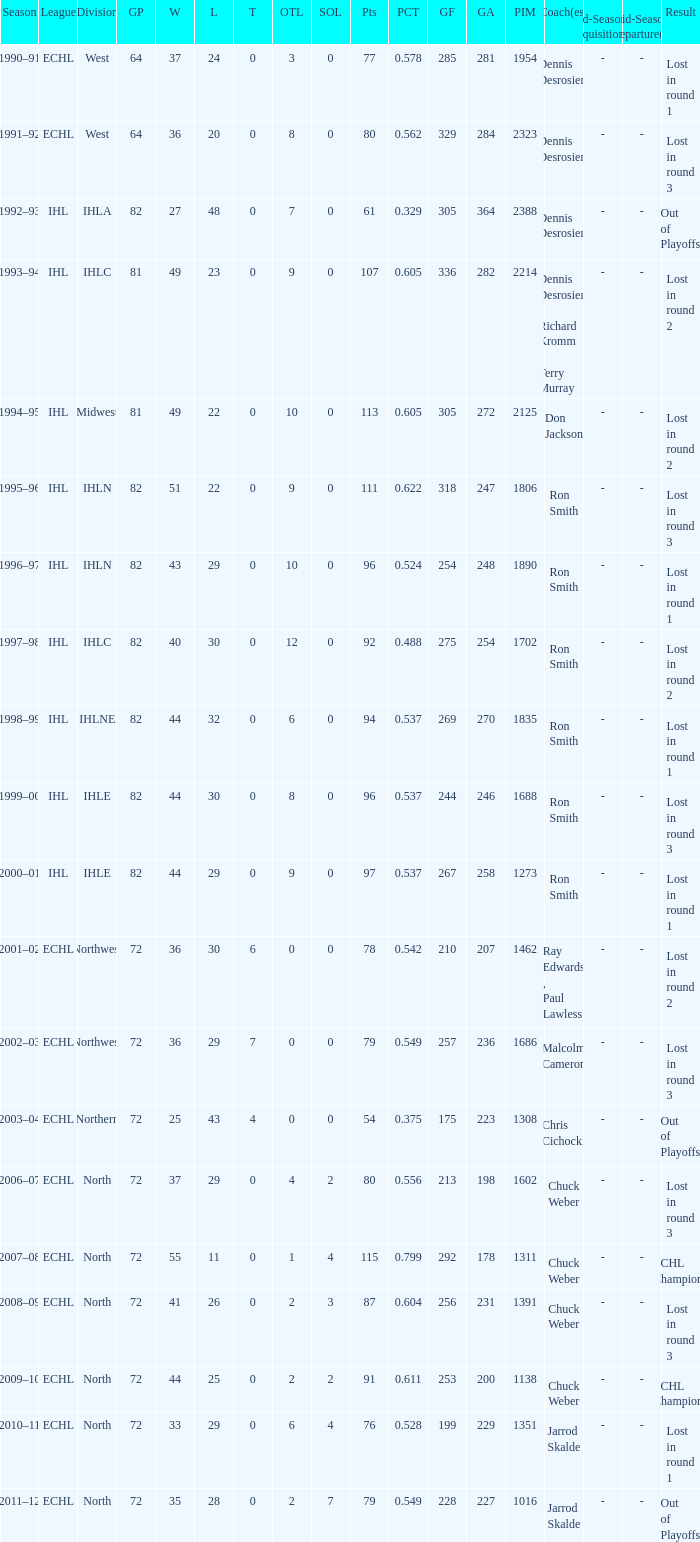What was the greatest sol when the team faced a loss in round 3? 3.0. 